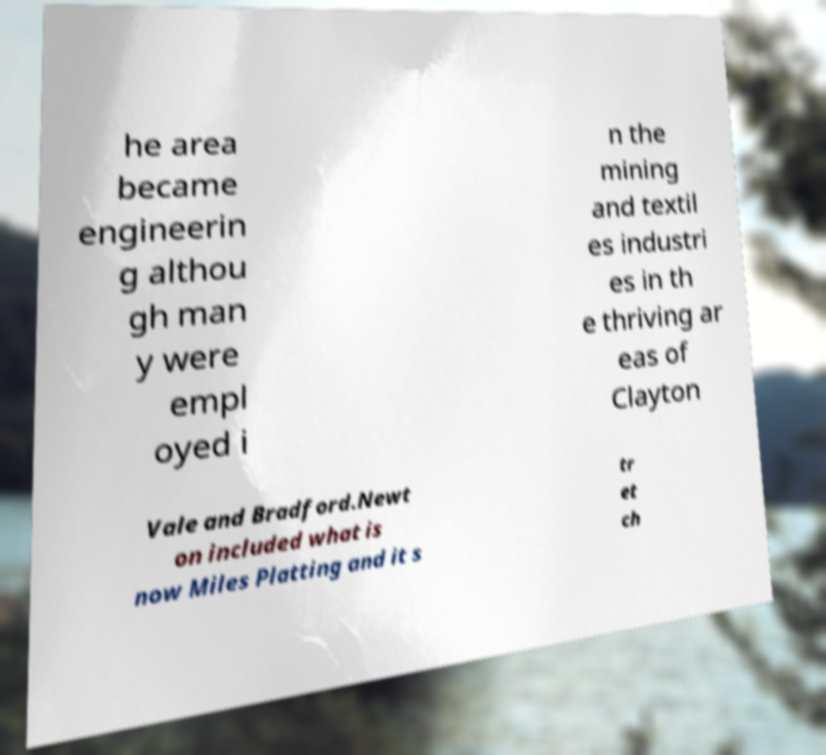Can you accurately transcribe the text from the provided image for me? he area became engineerin g althou gh man y were empl oyed i n the mining and textil es industri es in th e thriving ar eas of Clayton Vale and Bradford.Newt on included what is now Miles Platting and it s tr et ch 